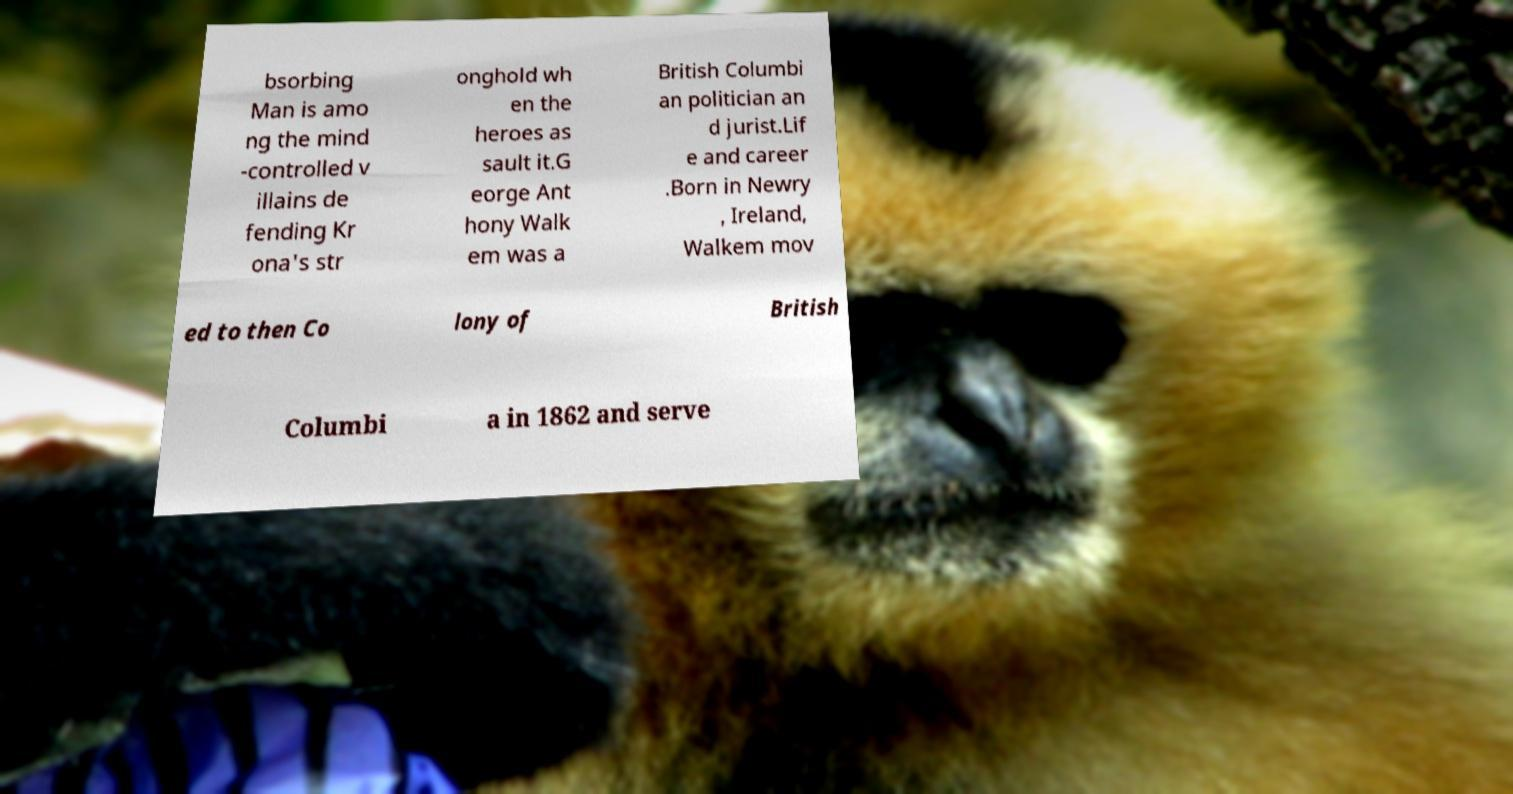Please read and relay the text visible in this image. What does it say? bsorbing Man is amo ng the mind -controlled v illains de fending Kr ona's str onghold wh en the heroes as sault it.G eorge Ant hony Walk em was a British Columbi an politician an d jurist.Lif e and career .Born in Newry , Ireland, Walkem mov ed to then Co lony of British Columbi a in 1862 and serve 